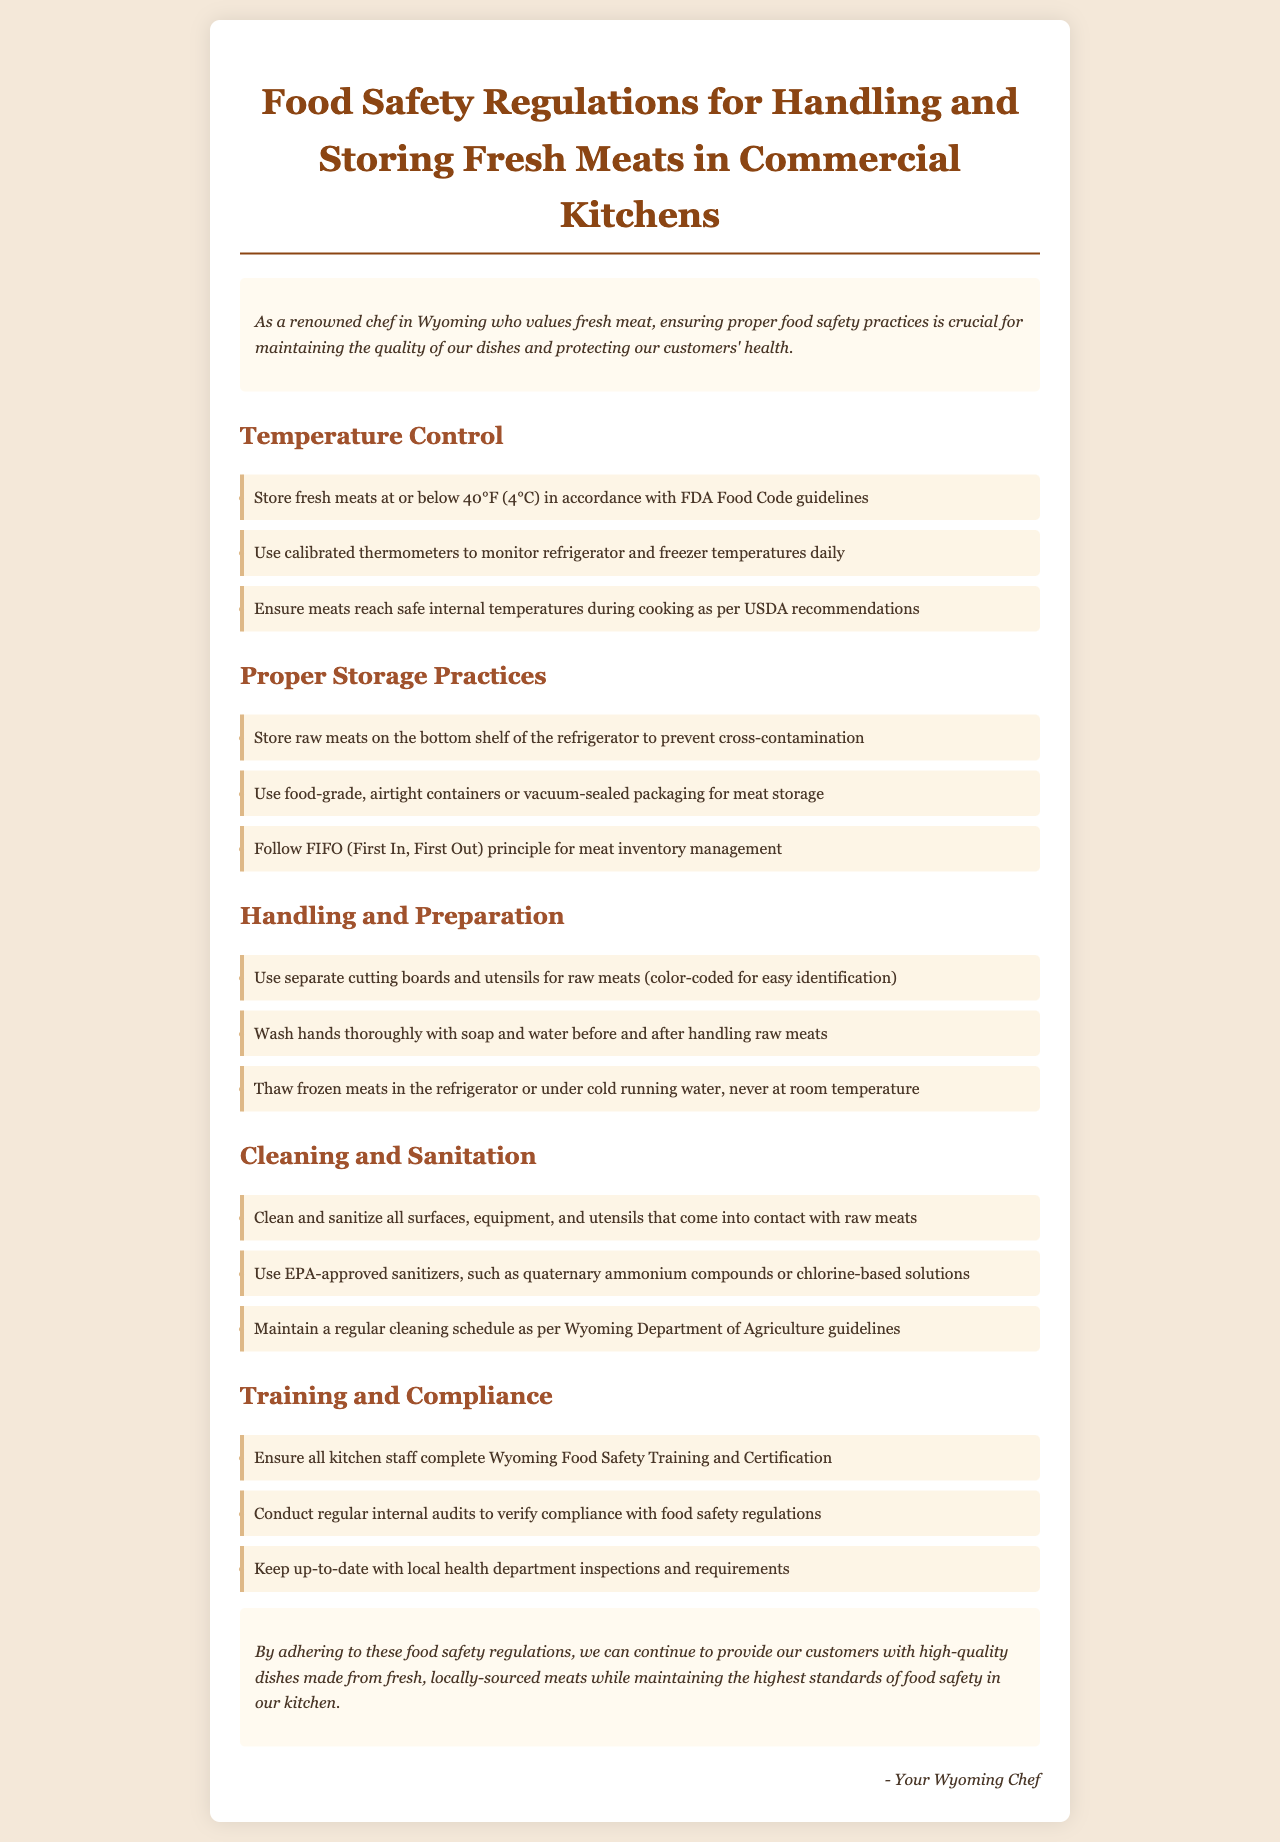What is the maximum storage temperature for fresh meats? The document states that fresh meats should be stored at or below 40°F (4°C).
Answer: 40°F (4°C) What is the FIFO principle in meat inventory management? FIFO stands for First In, First Out, which is a method for managing inventory.
Answer: First In, First Out What should be done before and after handling raw meats? The document advises washing hands thoroughly with soap and water.
Answer: Wash hands What type of thermometers should be used to monitor temperatures? The policy specifies using calibrated thermometers for monitoring.
Answer: Calibrated thermometers Which sanitizers are recommended for cleaning surfaces? The document mentions using EPA-approved sanitizers like quaternary ammonium compounds or chlorine-based solutions.
Answer: EPA-approved sanitizers How should frozen meats be thawed? It's stated that frozen meats should be thawed in the refrigerator or under cold running water, not at room temperature.
Answer: Refrigerator or cold running water What training must kitchen staff complete? According to the document, kitchen staff must complete Wyoming Food Safety Training and Certification.
Answer: Wyoming Food Safety Training and Certification What is required for meat storage to prevent cross-contamination? The guideline recommends storing raw meats on the bottom shelf of the refrigerator.
Answer: Bottom shelf What is the first point in the cleaning and sanitation section? The first point emphasizes the need to clean and sanitize all surfaces, equipment, and utensils that come into contact with raw meats.
Answer: Clean and sanitize all surfaces, equipment, and utensils 